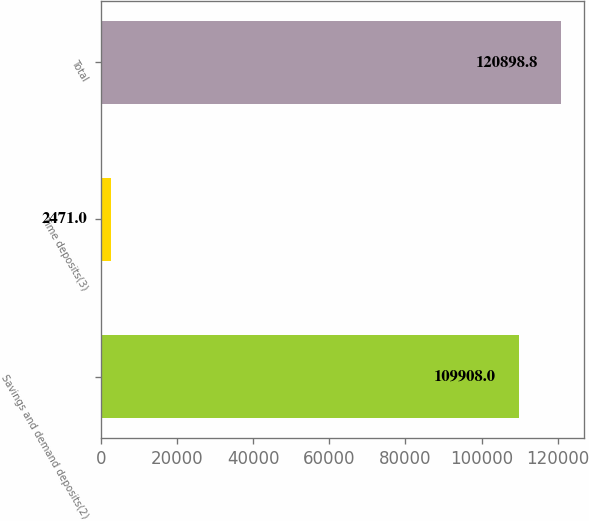Convert chart. <chart><loc_0><loc_0><loc_500><loc_500><bar_chart><fcel>Savings and demand deposits(2)<fcel>Time deposits(3)<fcel>Total<nl><fcel>109908<fcel>2471<fcel>120899<nl></chart> 